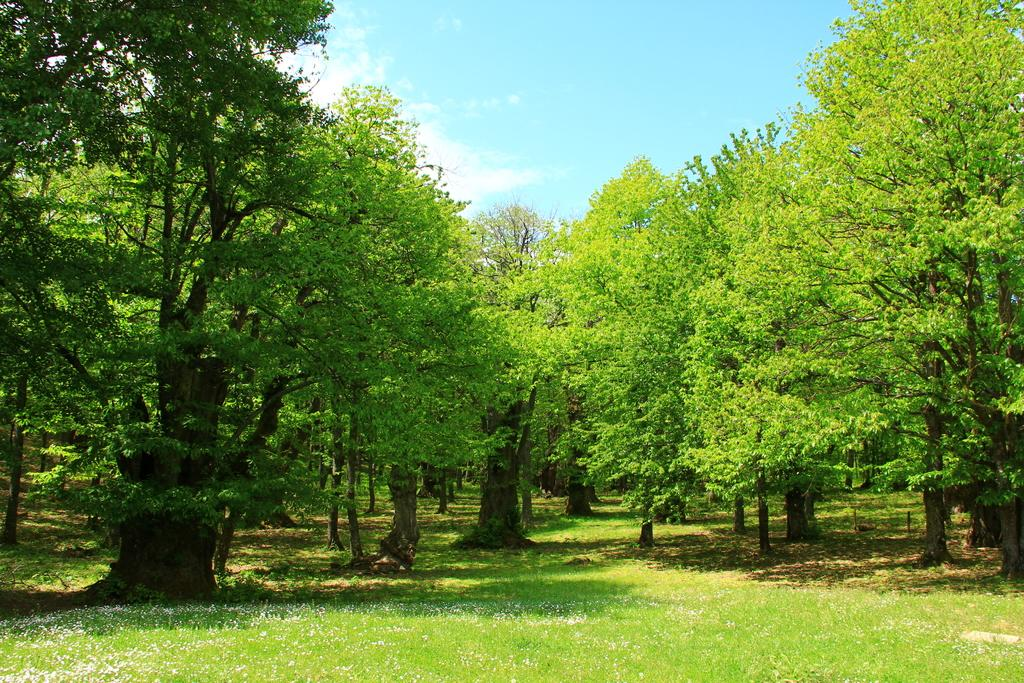What is visible on the ground in the image? The ground is visible in the image, and grass is present on the ground. What else can be seen in the image besides the ground? There are trees in the image. What is visible in the sky in the image? The sky is visible in the image, and clouds are present in the sky. Can you see a goose putting out a fire with a fireman in the image? No, there is no goose or fireman present in the image. What type of powder is being used to create the clouds in the image? There is no powder present in the image; the clouds are natural formations in the sky. 